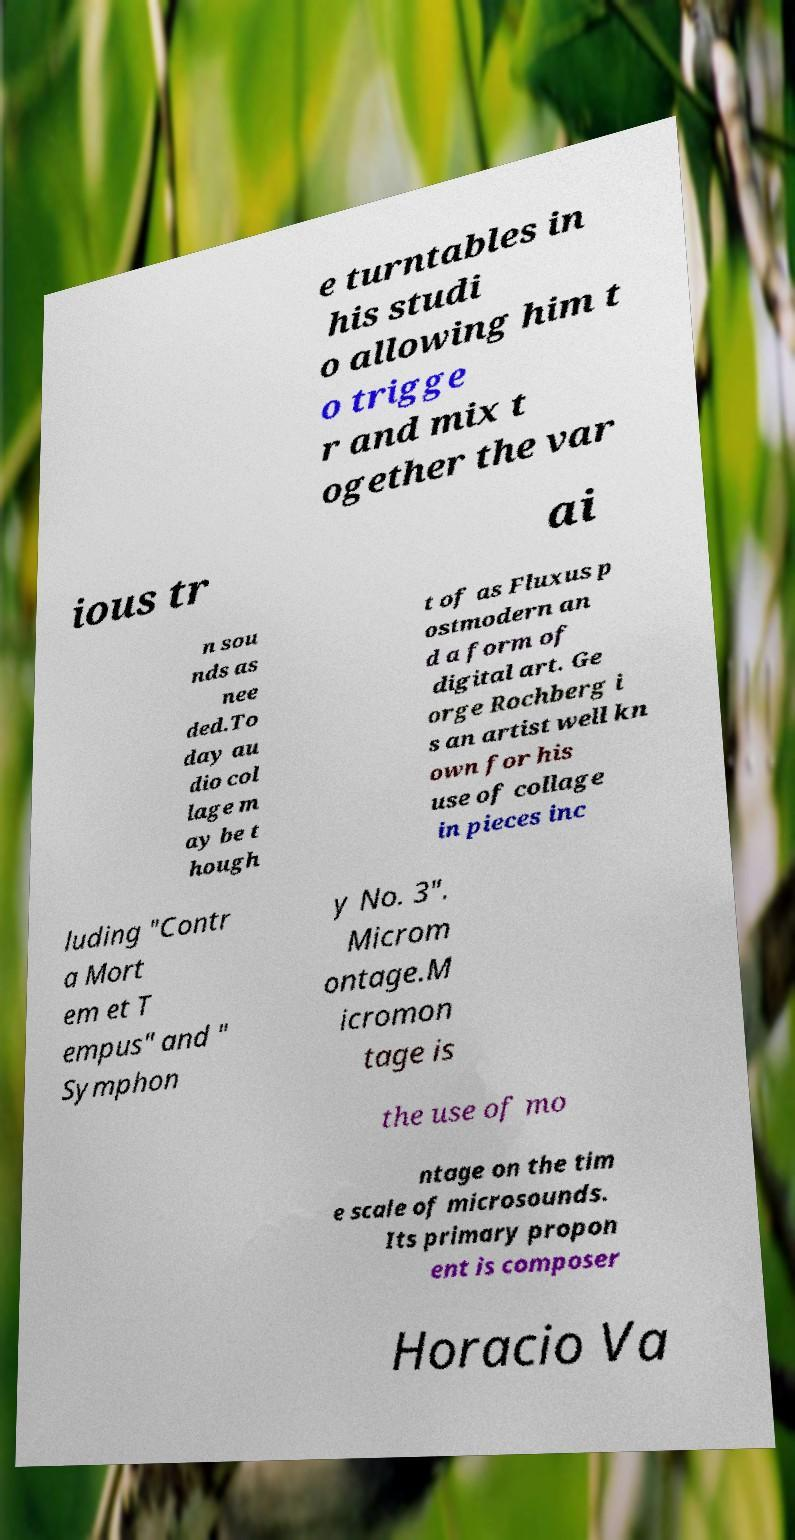What messages or text are displayed in this image? I need them in a readable, typed format. e turntables in his studi o allowing him t o trigge r and mix t ogether the var ious tr ai n sou nds as nee ded.To day au dio col lage m ay be t hough t of as Fluxus p ostmodern an d a form of digital art. Ge orge Rochberg i s an artist well kn own for his use of collage in pieces inc luding "Contr a Mort em et T empus" and " Symphon y No. 3". Microm ontage.M icromon tage is the use of mo ntage on the tim e scale of microsounds. Its primary propon ent is composer Horacio Va 